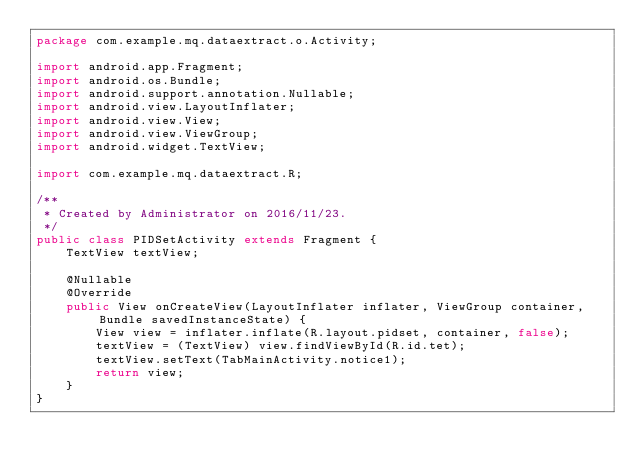Convert code to text. <code><loc_0><loc_0><loc_500><loc_500><_Java_>package com.example.mq.dataextract.o.Activity;

import android.app.Fragment;
import android.os.Bundle;
import android.support.annotation.Nullable;
import android.view.LayoutInflater;
import android.view.View;
import android.view.ViewGroup;
import android.widget.TextView;

import com.example.mq.dataextract.R;

/**
 * Created by Administrator on 2016/11/23.
 */
public class PIDSetActivity extends Fragment {
    TextView textView;

    @Nullable
    @Override
    public View onCreateView(LayoutInflater inflater, ViewGroup container, Bundle savedInstanceState) {
        View view = inflater.inflate(R.layout.pidset, container, false);
        textView = (TextView) view.findViewById(R.id.tet);
        textView.setText(TabMainActivity.notice1);
        return view;
    }
}
</code> 